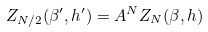Convert formula to latex. <formula><loc_0><loc_0><loc_500><loc_500>Z _ { N / 2 } ( \beta ^ { \prime } , h ^ { \prime } ) = A ^ { N } Z _ { N } ( \beta , h )</formula> 